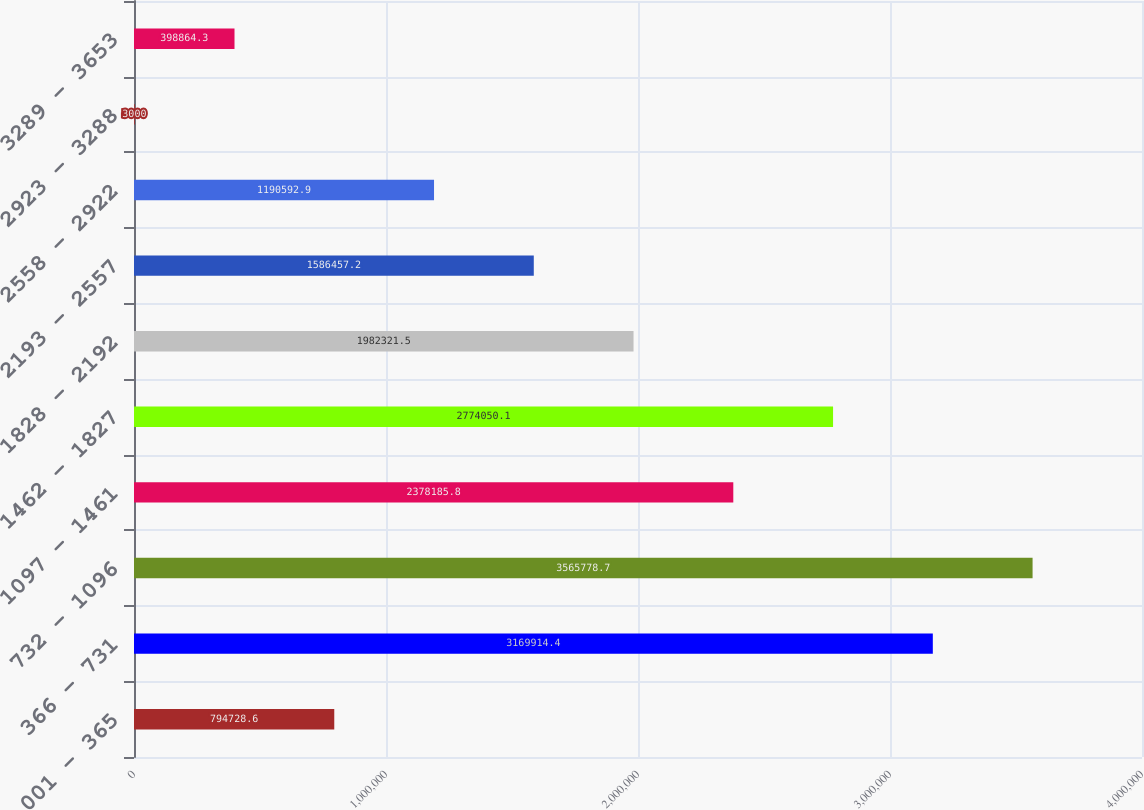<chart> <loc_0><loc_0><loc_500><loc_500><bar_chart><fcel>001 - 365<fcel>366 - 731<fcel>732 - 1096<fcel>1097 - 1461<fcel>1462 - 1827<fcel>1828 - 2192<fcel>2193 - 2557<fcel>2558 - 2922<fcel>2923 - 3288<fcel>3289 - 3653<nl><fcel>794729<fcel>3.16991e+06<fcel>3.56578e+06<fcel>2.37819e+06<fcel>2.77405e+06<fcel>1.98232e+06<fcel>1.58646e+06<fcel>1.19059e+06<fcel>3000<fcel>398864<nl></chart> 